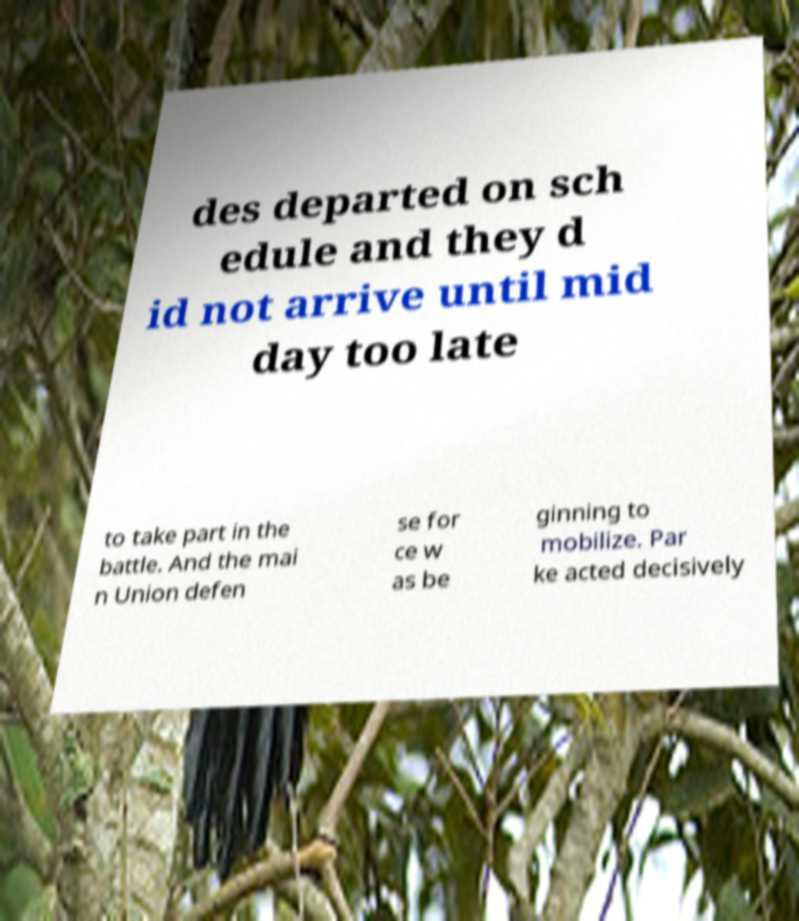Can you read and provide the text displayed in the image?This photo seems to have some interesting text. Can you extract and type it out for me? des departed on sch edule and they d id not arrive until mid day too late to take part in the battle. And the mai n Union defen se for ce w as be ginning to mobilize. Par ke acted decisively 